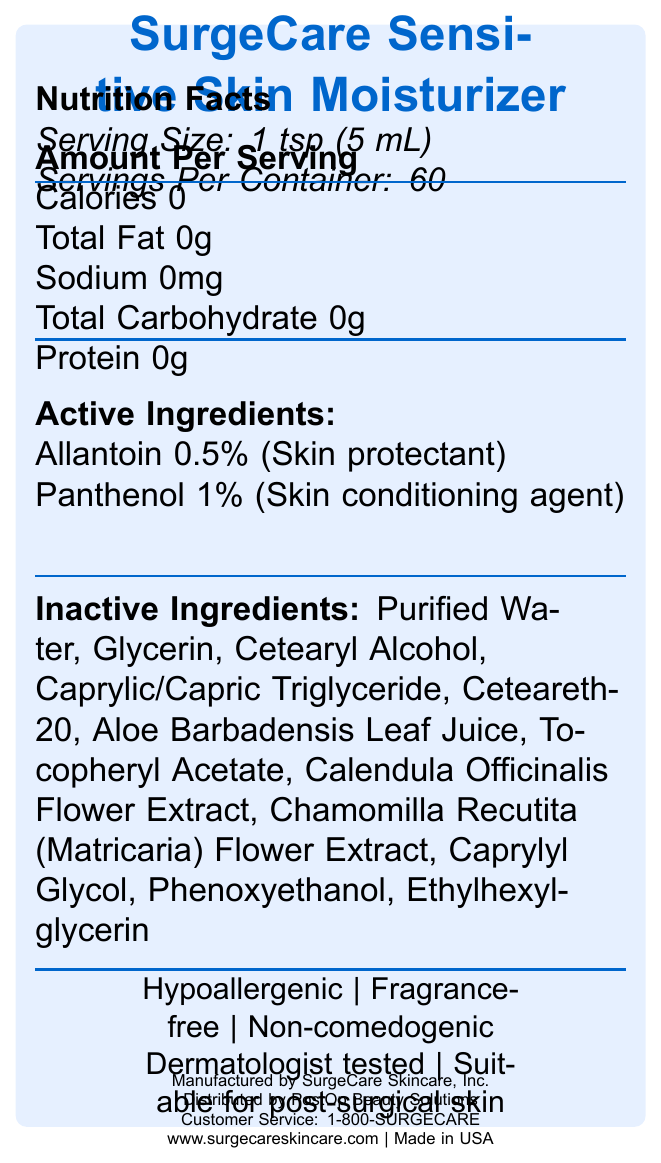what is the serving size? The serving size is explicitly stated at the beginning of the Nutrition Facts section.
Answer: 1 tsp (5 mL) How many servings are there per container? The servings per container are listed in the Nutrition Facts section.
Answer: 60 Name two active ingredients in the moisturizer. These active ingredients are listed in the Active Ingredients section with their respective percentages and purposes.
Answer: Allantoin, Panthenol What is the purpose of Panthenol in the moisturizer? The purpose of Panthenol is specified in the Active Ingredients section.
Answer: Skin conditioning agent What are some key features of this moisturizer? These features are listed at the bottom under key features.
Answer: Hypoallergenic, Fragrance-free, Non-comedogenic, Dermatologist tested, Suitable for post-surgical skin How often should the moisturizer be applied? A. Once daily B. 2-3 times daily C. Every hour D. As needed The application instructions state to apply a thin layer to clean, dry skin 2-3 times daily or as directed by a healthcare professional.
Answer: B Which ingredient is used as a skin protectant? A. Panthenol B. Allantoin C. Glycerin D. Aloe Barbadensis Leaf Juice Allantoin is listed as a skin protectant in the Active Ingredients section.
Answer: B Is this moisturizer suitable for use on open wounds? The warnings section clearly states not to use on open wounds or actively bleeding skin.
Answer: No Summarize the contents and purpose of this document. The document aims to inform users about the product's ingredients, benefits, and usage guidelines while providing safety information and contact details for further assistance.
Answer: This document provides detailed information about the SurgeCare Sensitive Skin Moisturizer. It includes the product's nutrition facts, serving size, active and inactive ingredients, key features, directions for use, warnings, storage information, manufacturer, distributor, customer service contact, and website. This moisturizer is designed for sensitive post-operative skin and is hypoallergenic, fragrance-free, non-comedogenic, and dermatologist tested. What is the calorie content per serving of this moisturizer? The nutritional facts section states that there are 0 calories per serving.
Answer: 0 Where is the moisturizer manufactured? The document states that it is made in the USA in the manufacturer information section.
Answer: USA Can I find the list of preservatives in the moisturizer from this document? The document does not specifically identify which ingredients serve as preservatives.
Answer: Not enough information What should you do if the moisturizer is swallowed? The warnings section provides this instruction.
Answer: Get medical help or contact a Poison Control Center immediately 